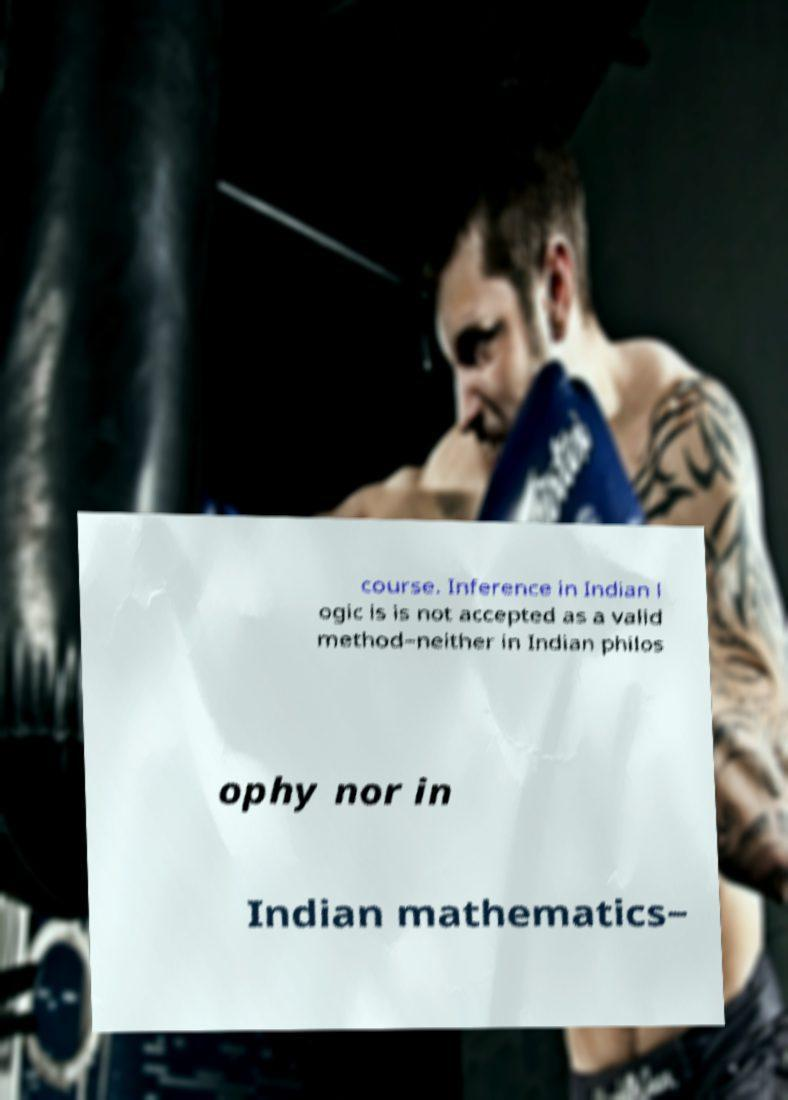What messages or text are displayed in this image? I need them in a readable, typed format. course. Inference in Indian l ogic is is not accepted as a valid method−neither in Indian philos ophy nor in Indian mathematics− 